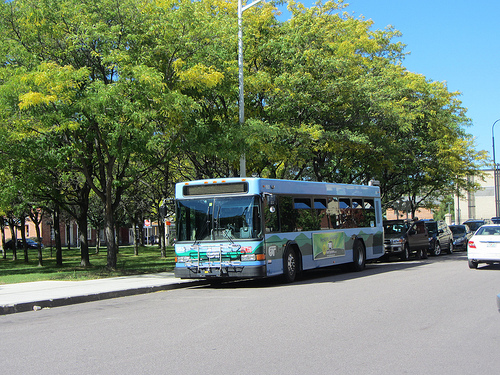Does the sky appear to be white? No, the sky does not appear to be white; it is clear and blue. 